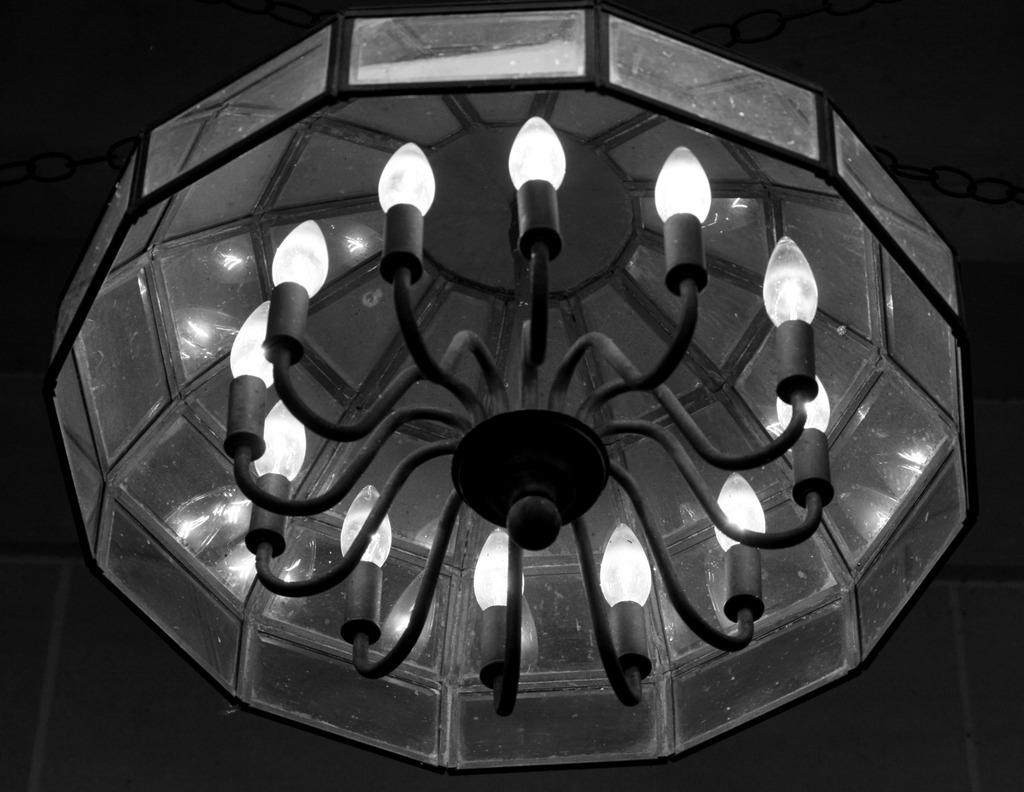What type of lighting fixture is present in the image? There is a chandelier in the image. Can you describe the lighting conditions in the image? The image is a little dark. Can you see a kitty flying an airplane in the image? No, there is no kitty or airplane present in the image. 